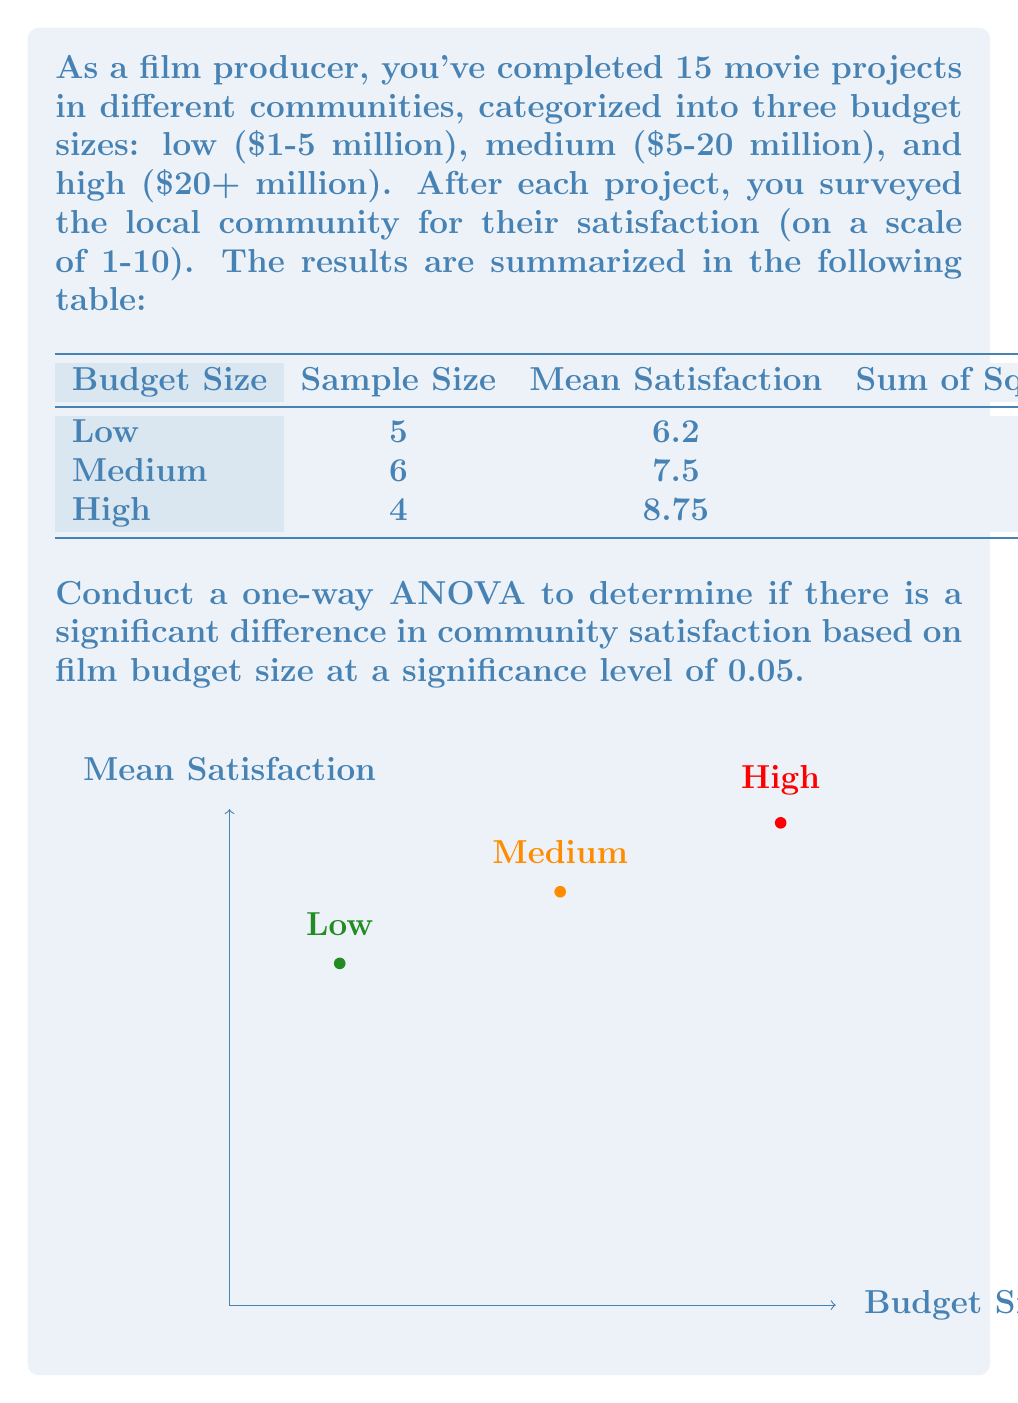What is the answer to this math problem? To conduct a one-way ANOVA, we'll follow these steps:

1. Calculate the Sum of Squares Between (SSB):
   $$SSB = \sum_{i=1}^k n_i(\bar{x}_i - \bar{x})^2$$
   where $k$ is the number of groups, $n_i$ is the sample size of each group, $\bar{x}_i$ is the mean of each group, and $\bar{x}$ is the grand mean.

   Grand mean: $\bar{x} = \frac{5(6.2) + 6(7.5) + 4(8.75)}{15} = 7.4$

   $$SSB = 5(6.2 - 7.4)^2 + 6(7.5 - 7.4)^2 + 4(8.75 - 7.4)^2 = 21.37$$

2. Calculate the Sum of Squares Within (SSW):
   SSW is the sum of squared deviations given in the table.
   $$SSW = 18.8 + 24.5 + 9.75 = 53.05$$

3. Calculate the Sum of Squares Total (SST):
   $$SST = SSB + SSW = 21.37 + 53.05 = 74.42$$

4. Calculate degrees of freedom:
   - Between groups: $df_B = k - 1 = 3 - 1 = 2$
   - Within groups: $df_W = N - k = 15 - 3 = 12$
   - Total: $df_T = N - 1 = 15 - 1 = 14$

5. Calculate Mean Squares:
   $$MS_B = \frac{SSB}{df_B} = \frac{21.37}{2} = 10.685$$
   $$MS_W = \frac{SSW}{df_W} = \frac{53.05}{12} = 4.4208$$

6. Calculate F-statistic:
   $$F = \frac{MS_B}{MS_W} = \frac{10.685}{4.4208} = 2.4169$$

7. Find the critical F-value:
   For $\alpha = 0.05$, $df_B = 2$, and $df_W = 12$, the critical F-value is approximately 3.89.

8. Compare F-statistic to critical F-value:
   Since $2.4169 < 3.89$, we fail to reject the null hypothesis.
Answer: Fail to reject null hypothesis; no significant difference in satisfaction based on budget size (F(2,12) = 2.4169, p > 0.05). 